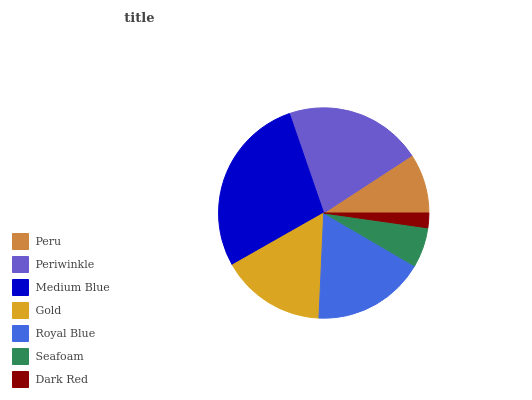Is Dark Red the minimum?
Answer yes or no. Yes. Is Medium Blue the maximum?
Answer yes or no. Yes. Is Periwinkle the minimum?
Answer yes or no. No. Is Periwinkle the maximum?
Answer yes or no. No. Is Periwinkle greater than Peru?
Answer yes or no. Yes. Is Peru less than Periwinkle?
Answer yes or no. Yes. Is Peru greater than Periwinkle?
Answer yes or no. No. Is Periwinkle less than Peru?
Answer yes or no. No. Is Gold the high median?
Answer yes or no. Yes. Is Gold the low median?
Answer yes or no. Yes. Is Peru the high median?
Answer yes or no. No. Is Seafoam the low median?
Answer yes or no. No. 